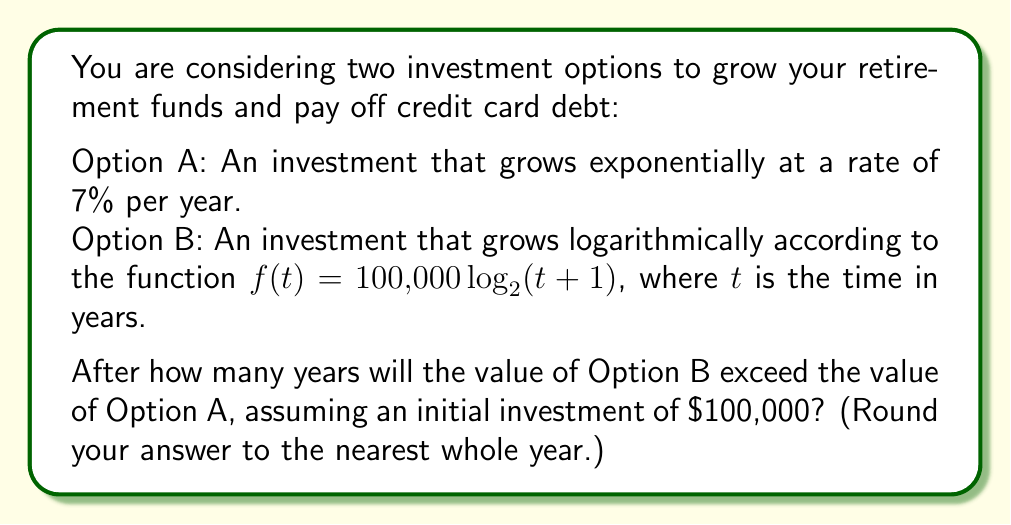Help me with this question. Let's approach this step-by-step:

1) For Option A, the value after $t$ years is given by the exponential function:
   $A(t) = 100,000 \cdot (1.07)^t$

2) For Option B, we're given the function:
   $B(t) = 100,000 \log_2(t+1)$

3) We need to find the value of $t$ where $B(t) > A(t)$:
   $100,000 \log_2(t+1) > 100,000 \cdot (1.07)^t$

4) Simplifying:
   $\log_2(t+1) > (1.07)^t$

5) To solve this, we can use a graphical method. We'll plot both sides of the inequality and find where they intersect.

6) Using a graphing calculator or software, we can see that the intersection occurs at approximately $t = 60.8$ years.

7) Since we're asked to round to the nearest whole year, our answer is 61 years.

8) We can verify:
   At $t = 61$:
   $A(61) = 100,000 \cdot (1.07)^{61} \approx 5,743,491$
   $B(61) = 100,000 \log_2(62) \approx 5,954,196$

   Indeed, $B(61) > A(61)$

Therefore, after 61 years, the logarithmic growth of Option B will exceed the exponential growth of Option A.
Answer: 61 years 